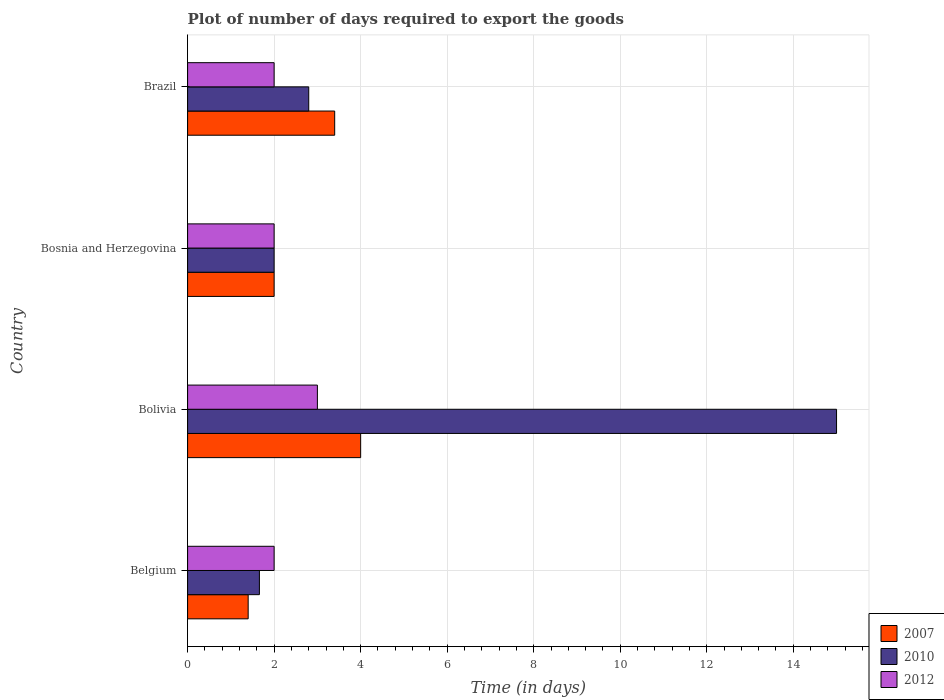Are the number of bars on each tick of the Y-axis equal?
Offer a terse response. Yes. How many bars are there on the 2nd tick from the top?
Your answer should be very brief. 3. How many bars are there on the 2nd tick from the bottom?
Keep it short and to the point. 3. What is the label of the 2nd group of bars from the top?
Provide a succinct answer. Bosnia and Herzegovina. What is the time required to export goods in 2010 in Belgium?
Give a very brief answer. 1.66. Across all countries, what is the minimum time required to export goods in 2010?
Offer a very short reply. 1.66. In which country was the time required to export goods in 2007 maximum?
Give a very brief answer. Bolivia. What is the total time required to export goods in 2010 in the graph?
Your response must be concise. 21.46. What is the difference between the time required to export goods in 2010 in Belgium and that in Brazil?
Your answer should be very brief. -1.14. What is the difference between the time required to export goods in 2012 in Bosnia and Herzegovina and the time required to export goods in 2010 in Brazil?
Provide a succinct answer. -0.8. What is the average time required to export goods in 2007 per country?
Your answer should be compact. 2.7. What is the difference between the time required to export goods in 2007 and time required to export goods in 2010 in Brazil?
Keep it short and to the point. 0.6. In how many countries, is the time required to export goods in 2010 greater than 14.8 days?
Provide a succinct answer. 1. What is the ratio of the time required to export goods in 2007 in Bolivia to that in Bosnia and Herzegovina?
Your answer should be compact. 2. Is the time required to export goods in 2012 in Bolivia less than that in Brazil?
Your answer should be very brief. No. Is the difference between the time required to export goods in 2007 in Bosnia and Herzegovina and Brazil greater than the difference between the time required to export goods in 2010 in Bosnia and Herzegovina and Brazil?
Keep it short and to the point. No. What is the difference between the highest and the second highest time required to export goods in 2007?
Your answer should be compact. 0.6. In how many countries, is the time required to export goods in 2010 greater than the average time required to export goods in 2010 taken over all countries?
Provide a short and direct response. 1. What does the 2nd bar from the top in Bolivia represents?
Your response must be concise. 2010. Are all the bars in the graph horizontal?
Keep it short and to the point. Yes. Are the values on the major ticks of X-axis written in scientific E-notation?
Offer a terse response. No. How are the legend labels stacked?
Your answer should be very brief. Vertical. What is the title of the graph?
Make the answer very short. Plot of number of days required to export the goods. What is the label or title of the X-axis?
Provide a succinct answer. Time (in days). What is the Time (in days) in 2010 in Belgium?
Ensure brevity in your answer.  1.66. What is the Time (in days) of 2007 in Bolivia?
Your answer should be compact. 4. What is the Time (in days) in 2010 in Bolivia?
Your response must be concise. 15. What is the Time (in days) of 2010 in Bosnia and Herzegovina?
Your answer should be very brief. 2. Across all countries, what is the maximum Time (in days) of 2012?
Provide a succinct answer. 3. Across all countries, what is the minimum Time (in days) in 2007?
Your response must be concise. 1.4. Across all countries, what is the minimum Time (in days) of 2010?
Your response must be concise. 1.66. What is the total Time (in days) of 2007 in the graph?
Offer a very short reply. 10.8. What is the total Time (in days) of 2010 in the graph?
Your answer should be very brief. 21.46. What is the total Time (in days) in 2012 in the graph?
Give a very brief answer. 9. What is the difference between the Time (in days) in 2007 in Belgium and that in Bolivia?
Offer a terse response. -2.6. What is the difference between the Time (in days) in 2010 in Belgium and that in Bolivia?
Make the answer very short. -13.34. What is the difference between the Time (in days) in 2012 in Belgium and that in Bolivia?
Your answer should be compact. -1. What is the difference between the Time (in days) of 2007 in Belgium and that in Bosnia and Herzegovina?
Ensure brevity in your answer.  -0.6. What is the difference between the Time (in days) of 2010 in Belgium and that in Bosnia and Herzegovina?
Offer a very short reply. -0.34. What is the difference between the Time (in days) of 2010 in Belgium and that in Brazil?
Make the answer very short. -1.14. What is the difference between the Time (in days) of 2007 in Bolivia and that in Bosnia and Herzegovina?
Offer a terse response. 2. What is the difference between the Time (in days) in 2010 in Bolivia and that in Bosnia and Herzegovina?
Offer a terse response. 13. What is the difference between the Time (in days) in 2007 in Bolivia and that in Brazil?
Your response must be concise. 0.6. What is the difference between the Time (in days) of 2007 in Bosnia and Herzegovina and that in Brazil?
Offer a terse response. -1.4. What is the difference between the Time (in days) in 2010 in Bosnia and Herzegovina and that in Brazil?
Your answer should be compact. -0.8. What is the difference between the Time (in days) in 2007 in Belgium and the Time (in days) in 2010 in Bolivia?
Your answer should be compact. -13.6. What is the difference between the Time (in days) in 2007 in Belgium and the Time (in days) in 2012 in Bolivia?
Make the answer very short. -1.6. What is the difference between the Time (in days) in 2010 in Belgium and the Time (in days) in 2012 in Bolivia?
Keep it short and to the point. -1.34. What is the difference between the Time (in days) of 2010 in Belgium and the Time (in days) of 2012 in Bosnia and Herzegovina?
Give a very brief answer. -0.34. What is the difference between the Time (in days) in 2007 in Belgium and the Time (in days) in 2010 in Brazil?
Offer a very short reply. -1.4. What is the difference between the Time (in days) of 2010 in Belgium and the Time (in days) of 2012 in Brazil?
Ensure brevity in your answer.  -0.34. What is the difference between the Time (in days) of 2010 in Bolivia and the Time (in days) of 2012 in Bosnia and Herzegovina?
Offer a terse response. 13. What is the difference between the Time (in days) in 2007 in Bolivia and the Time (in days) in 2010 in Brazil?
Ensure brevity in your answer.  1.2. What is the difference between the Time (in days) of 2010 in Bolivia and the Time (in days) of 2012 in Brazil?
Keep it short and to the point. 13. What is the difference between the Time (in days) of 2007 in Bosnia and Herzegovina and the Time (in days) of 2010 in Brazil?
Offer a terse response. -0.8. What is the difference between the Time (in days) in 2007 in Bosnia and Herzegovina and the Time (in days) in 2012 in Brazil?
Your response must be concise. 0. What is the difference between the Time (in days) in 2010 in Bosnia and Herzegovina and the Time (in days) in 2012 in Brazil?
Your response must be concise. 0. What is the average Time (in days) in 2010 per country?
Keep it short and to the point. 5.37. What is the average Time (in days) of 2012 per country?
Offer a very short reply. 2.25. What is the difference between the Time (in days) in 2007 and Time (in days) in 2010 in Belgium?
Offer a very short reply. -0.26. What is the difference between the Time (in days) of 2007 and Time (in days) of 2012 in Belgium?
Your answer should be very brief. -0.6. What is the difference between the Time (in days) in 2010 and Time (in days) in 2012 in Belgium?
Provide a succinct answer. -0.34. What is the difference between the Time (in days) of 2007 and Time (in days) of 2010 in Bolivia?
Make the answer very short. -11. What is the difference between the Time (in days) in 2007 and Time (in days) in 2012 in Bolivia?
Give a very brief answer. 1. What is the difference between the Time (in days) of 2007 and Time (in days) of 2010 in Bosnia and Herzegovina?
Give a very brief answer. 0. What is the difference between the Time (in days) of 2007 and Time (in days) of 2012 in Bosnia and Herzegovina?
Offer a very short reply. 0. What is the difference between the Time (in days) in 2007 and Time (in days) in 2012 in Brazil?
Give a very brief answer. 1.4. What is the ratio of the Time (in days) in 2010 in Belgium to that in Bolivia?
Offer a terse response. 0.11. What is the ratio of the Time (in days) in 2010 in Belgium to that in Bosnia and Herzegovina?
Make the answer very short. 0.83. What is the ratio of the Time (in days) of 2012 in Belgium to that in Bosnia and Herzegovina?
Make the answer very short. 1. What is the ratio of the Time (in days) in 2007 in Belgium to that in Brazil?
Offer a very short reply. 0.41. What is the ratio of the Time (in days) in 2010 in Belgium to that in Brazil?
Ensure brevity in your answer.  0.59. What is the ratio of the Time (in days) of 2007 in Bolivia to that in Brazil?
Offer a terse response. 1.18. What is the ratio of the Time (in days) in 2010 in Bolivia to that in Brazil?
Offer a very short reply. 5.36. What is the ratio of the Time (in days) in 2007 in Bosnia and Herzegovina to that in Brazil?
Your answer should be compact. 0.59. What is the ratio of the Time (in days) of 2010 in Bosnia and Herzegovina to that in Brazil?
Your answer should be very brief. 0.71. What is the difference between the highest and the second highest Time (in days) of 2007?
Your answer should be very brief. 0.6. What is the difference between the highest and the second highest Time (in days) in 2010?
Ensure brevity in your answer.  12.2. What is the difference between the highest and the lowest Time (in days) in 2010?
Your answer should be very brief. 13.34. What is the difference between the highest and the lowest Time (in days) in 2012?
Provide a short and direct response. 1. 